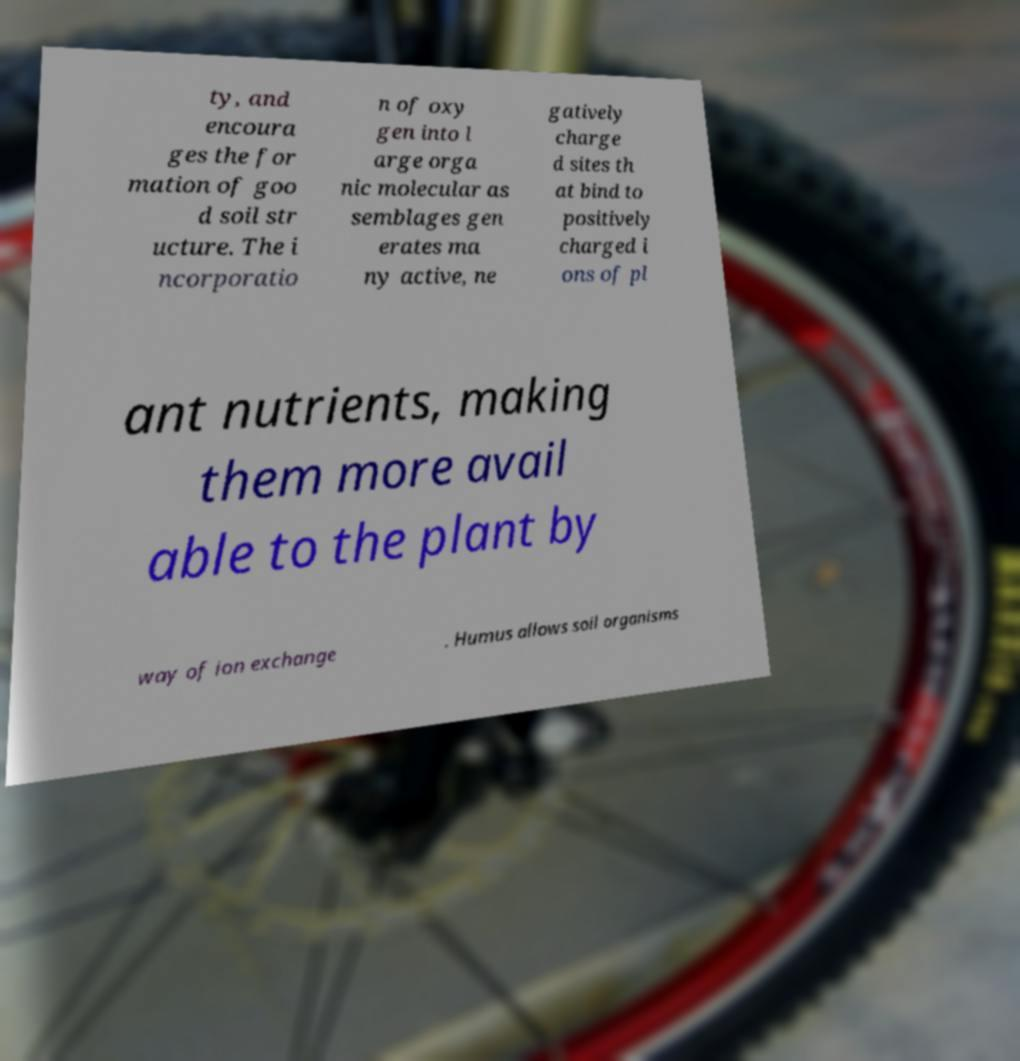Could you extract and type out the text from this image? ty, and encoura ges the for mation of goo d soil str ucture. The i ncorporatio n of oxy gen into l arge orga nic molecular as semblages gen erates ma ny active, ne gatively charge d sites th at bind to positively charged i ons of pl ant nutrients, making them more avail able to the plant by way of ion exchange . Humus allows soil organisms 